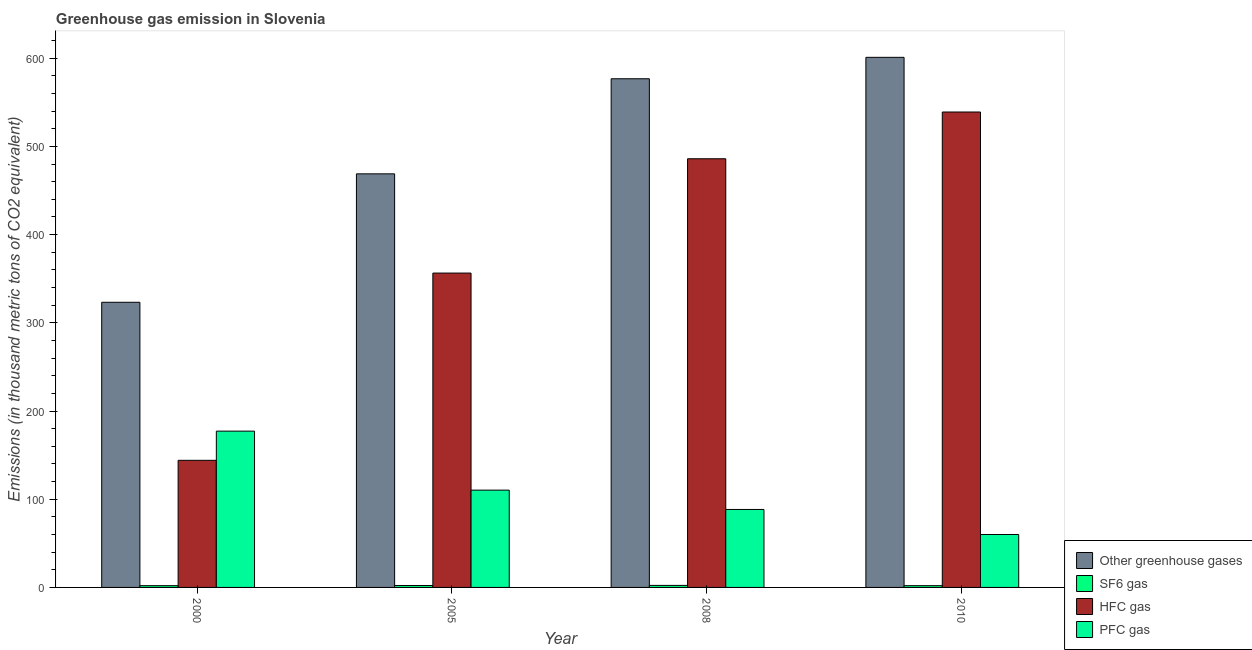How many groups of bars are there?
Ensure brevity in your answer.  4. Are the number of bars per tick equal to the number of legend labels?
Offer a very short reply. Yes. Are the number of bars on each tick of the X-axis equal?
Your response must be concise. Yes. What is the label of the 4th group of bars from the left?
Offer a terse response. 2010. In how many cases, is the number of bars for a given year not equal to the number of legend labels?
Give a very brief answer. 0. What is the emission of sf6 gas in 2000?
Your response must be concise. 2. Across all years, what is the maximum emission of greenhouse gases?
Provide a succinct answer. 601. What is the total emission of pfc gas in the graph?
Give a very brief answer. 435.9. What is the difference between the emission of sf6 gas in 2005 and the emission of pfc gas in 2008?
Your answer should be very brief. -0.1. What is the average emission of sf6 gas per year?
Offer a very short reply. 2.12. In how many years, is the emission of greenhouse gases greater than 500 thousand metric tons?
Give a very brief answer. 2. What is the ratio of the emission of sf6 gas in 2000 to that in 2008?
Ensure brevity in your answer.  0.87. Is the emission of greenhouse gases in 2000 less than that in 2010?
Offer a very short reply. Yes. What is the difference between the highest and the second highest emission of pfc gas?
Give a very brief answer. 66.9. What is the difference between the highest and the lowest emission of pfc gas?
Offer a very short reply. 117.2. What does the 4th bar from the left in 2005 represents?
Keep it short and to the point. PFC gas. What does the 1st bar from the right in 2000 represents?
Ensure brevity in your answer.  PFC gas. Is it the case that in every year, the sum of the emission of greenhouse gases and emission of sf6 gas is greater than the emission of hfc gas?
Keep it short and to the point. Yes. Are all the bars in the graph horizontal?
Offer a very short reply. No. How many years are there in the graph?
Your answer should be compact. 4. What is the difference between two consecutive major ticks on the Y-axis?
Ensure brevity in your answer.  100. Does the graph contain any zero values?
Offer a terse response. No. Does the graph contain grids?
Your response must be concise. No. How many legend labels are there?
Your response must be concise. 4. How are the legend labels stacked?
Offer a terse response. Vertical. What is the title of the graph?
Ensure brevity in your answer.  Greenhouse gas emission in Slovenia. What is the label or title of the X-axis?
Your answer should be very brief. Year. What is the label or title of the Y-axis?
Ensure brevity in your answer.  Emissions (in thousand metric tons of CO2 equivalent). What is the Emissions (in thousand metric tons of CO2 equivalent) in Other greenhouse gases in 2000?
Make the answer very short. 323.3. What is the Emissions (in thousand metric tons of CO2 equivalent) of HFC gas in 2000?
Keep it short and to the point. 144.1. What is the Emissions (in thousand metric tons of CO2 equivalent) of PFC gas in 2000?
Your response must be concise. 177.2. What is the Emissions (in thousand metric tons of CO2 equivalent) of Other greenhouse gases in 2005?
Provide a succinct answer. 468.9. What is the Emissions (in thousand metric tons of CO2 equivalent) of HFC gas in 2005?
Offer a very short reply. 356.4. What is the Emissions (in thousand metric tons of CO2 equivalent) in PFC gas in 2005?
Provide a short and direct response. 110.3. What is the Emissions (in thousand metric tons of CO2 equivalent) of Other greenhouse gases in 2008?
Your answer should be compact. 576.7. What is the Emissions (in thousand metric tons of CO2 equivalent) of HFC gas in 2008?
Give a very brief answer. 486. What is the Emissions (in thousand metric tons of CO2 equivalent) in PFC gas in 2008?
Provide a succinct answer. 88.4. What is the Emissions (in thousand metric tons of CO2 equivalent) of Other greenhouse gases in 2010?
Your answer should be very brief. 601. What is the Emissions (in thousand metric tons of CO2 equivalent) of HFC gas in 2010?
Your answer should be compact. 539. Across all years, what is the maximum Emissions (in thousand metric tons of CO2 equivalent) of Other greenhouse gases?
Ensure brevity in your answer.  601. Across all years, what is the maximum Emissions (in thousand metric tons of CO2 equivalent) of HFC gas?
Offer a terse response. 539. Across all years, what is the maximum Emissions (in thousand metric tons of CO2 equivalent) in PFC gas?
Offer a terse response. 177.2. Across all years, what is the minimum Emissions (in thousand metric tons of CO2 equivalent) in Other greenhouse gases?
Give a very brief answer. 323.3. Across all years, what is the minimum Emissions (in thousand metric tons of CO2 equivalent) of HFC gas?
Your answer should be compact. 144.1. Across all years, what is the minimum Emissions (in thousand metric tons of CO2 equivalent) of PFC gas?
Provide a succinct answer. 60. What is the total Emissions (in thousand metric tons of CO2 equivalent) in Other greenhouse gases in the graph?
Your response must be concise. 1969.9. What is the total Emissions (in thousand metric tons of CO2 equivalent) in SF6 gas in the graph?
Provide a succinct answer. 8.5. What is the total Emissions (in thousand metric tons of CO2 equivalent) in HFC gas in the graph?
Your answer should be compact. 1525.5. What is the total Emissions (in thousand metric tons of CO2 equivalent) in PFC gas in the graph?
Give a very brief answer. 435.9. What is the difference between the Emissions (in thousand metric tons of CO2 equivalent) of Other greenhouse gases in 2000 and that in 2005?
Ensure brevity in your answer.  -145.6. What is the difference between the Emissions (in thousand metric tons of CO2 equivalent) of SF6 gas in 2000 and that in 2005?
Your answer should be compact. -0.2. What is the difference between the Emissions (in thousand metric tons of CO2 equivalent) of HFC gas in 2000 and that in 2005?
Your answer should be very brief. -212.3. What is the difference between the Emissions (in thousand metric tons of CO2 equivalent) of PFC gas in 2000 and that in 2005?
Your response must be concise. 66.9. What is the difference between the Emissions (in thousand metric tons of CO2 equivalent) in Other greenhouse gases in 2000 and that in 2008?
Keep it short and to the point. -253.4. What is the difference between the Emissions (in thousand metric tons of CO2 equivalent) in HFC gas in 2000 and that in 2008?
Give a very brief answer. -341.9. What is the difference between the Emissions (in thousand metric tons of CO2 equivalent) in PFC gas in 2000 and that in 2008?
Your answer should be compact. 88.8. What is the difference between the Emissions (in thousand metric tons of CO2 equivalent) of Other greenhouse gases in 2000 and that in 2010?
Your answer should be compact. -277.7. What is the difference between the Emissions (in thousand metric tons of CO2 equivalent) of SF6 gas in 2000 and that in 2010?
Offer a very short reply. 0. What is the difference between the Emissions (in thousand metric tons of CO2 equivalent) in HFC gas in 2000 and that in 2010?
Provide a succinct answer. -394.9. What is the difference between the Emissions (in thousand metric tons of CO2 equivalent) in PFC gas in 2000 and that in 2010?
Your response must be concise. 117.2. What is the difference between the Emissions (in thousand metric tons of CO2 equivalent) of Other greenhouse gases in 2005 and that in 2008?
Make the answer very short. -107.8. What is the difference between the Emissions (in thousand metric tons of CO2 equivalent) in HFC gas in 2005 and that in 2008?
Provide a short and direct response. -129.6. What is the difference between the Emissions (in thousand metric tons of CO2 equivalent) in PFC gas in 2005 and that in 2008?
Offer a very short reply. 21.9. What is the difference between the Emissions (in thousand metric tons of CO2 equivalent) of Other greenhouse gases in 2005 and that in 2010?
Provide a short and direct response. -132.1. What is the difference between the Emissions (in thousand metric tons of CO2 equivalent) in SF6 gas in 2005 and that in 2010?
Ensure brevity in your answer.  0.2. What is the difference between the Emissions (in thousand metric tons of CO2 equivalent) in HFC gas in 2005 and that in 2010?
Keep it short and to the point. -182.6. What is the difference between the Emissions (in thousand metric tons of CO2 equivalent) of PFC gas in 2005 and that in 2010?
Give a very brief answer. 50.3. What is the difference between the Emissions (in thousand metric tons of CO2 equivalent) of Other greenhouse gases in 2008 and that in 2010?
Your response must be concise. -24.3. What is the difference between the Emissions (in thousand metric tons of CO2 equivalent) in SF6 gas in 2008 and that in 2010?
Your answer should be compact. 0.3. What is the difference between the Emissions (in thousand metric tons of CO2 equivalent) of HFC gas in 2008 and that in 2010?
Give a very brief answer. -53. What is the difference between the Emissions (in thousand metric tons of CO2 equivalent) in PFC gas in 2008 and that in 2010?
Your answer should be very brief. 28.4. What is the difference between the Emissions (in thousand metric tons of CO2 equivalent) in Other greenhouse gases in 2000 and the Emissions (in thousand metric tons of CO2 equivalent) in SF6 gas in 2005?
Give a very brief answer. 321.1. What is the difference between the Emissions (in thousand metric tons of CO2 equivalent) of Other greenhouse gases in 2000 and the Emissions (in thousand metric tons of CO2 equivalent) of HFC gas in 2005?
Offer a terse response. -33.1. What is the difference between the Emissions (in thousand metric tons of CO2 equivalent) in Other greenhouse gases in 2000 and the Emissions (in thousand metric tons of CO2 equivalent) in PFC gas in 2005?
Provide a succinct answer. 213. What is the difference between the Emissions (in thousand metric tons of CO2 equivalent) of SF6 gas in 2000 and the Emissions (in thousand metric tons of CO2 equivalent) of HFC gas in 2005?
Your answer should be compact. -354.4. What is the difference between the Emissions (in thousand metric tons of CO2 equivalent) in SF6 gas in 2000 and the Emissions (in thousand metric tons of CO2 equivalent) in PFC gas in 2005?
Provide a short and direct response. -108.3. What is the difference between the Emissions (in thousand metric tons of CO2 equivalent) in HFC gas in 2000 and the Emissions (in thousand metric tons of CO2 equivalent) in PFC gas in 2005?
Ensure brevity in your answer.  33.8. What is the difference between the Emissions (in thousand metric tons of CO2 equivalent) in Other greenhouse gases in 2000 and the Emissions (in thousand metric tons of CO2 equivalent) in SF6 gas in 2008?
Give a very brief answer. 321. What is the difference between the Emissions (in thousand metric tons of CO2 equivalent) in Other greenhouse gases in 2000 and the Emissions (in thousand metric tons of CO2 equivalent) in HFC gas in 2008?
Your answer should be very brief. -162.7. What is the difference between the Emissions (in thousand metric tons of CO2 equivalent) in Other greenhouse gases in 2000 and the Emissions (in thousand metric tons of CO2 equivalent) in PFC gas in 2008?
Offer a terse response. 234.9. What is the difference between the Emissions (in thousand metric tons of CO2 equivalent) of SF6 gas in 2000 and the Emissions (in thousand metric tons of CO2 equivalent) of HFC gas in 2008?
Provide a succinct answer. -484. What is the difference between the Emissions (in thousand metric tons of CO2 equivalent) in SF6 gas in 2000 and the Emissions (in thousand metric tons of CO2 equivalent) in PFC gas in 2008?
Keep it short and to the point. -86.4. What is the difference between the Emissions (in thousand metric tons of CO2 equivalent) of HFC gas in 2000 and the Emissions (in thousand metric tons of CO2 equivalent) of PFC gas in 2008?
Provide a short and direct response. 55.7. What is the difference between the Emissions (in thousand metric tons of CO2 equivalent) in Other greenhouse gases in 2000 and the Emissions (in thousand metric tons of CO2 equivalent) in SF6 gas in 2010?
Keep it short and to the point. 321.3. What is the difference between the Emissions (in thousand metric tons of CO2 equivalent) in Other greenhouse gases in 2000 and the Emissions (in thousand metric tons of CO2 equivalent) in HFC gas in 2010?
Give a very brief answer. -215.7. What is the difference between the Emissions (in thousand metric tons of CO2 equivalent) in Other greenhouse gases in 2000 and the Emissions (in thousand metric tons of CO2 equivalent) in PFC gas in 2010?
Your answer should be compact. 263.3. What is the difference between the Emissions (in thousand metric tons of CO2 equivalent) in SF6 gas in 2000 and the Emissions (in thousand metric tons of CO2 equivalent) in HFC gas in 2010?
Keep it short and to the point. -537. What is the difference between the Emissions (in thousand metric tons of CO2 equivalent) in SF6 gas in 2000 and the Emissions (in thousand metric tons of CO2 equivalent) in PFC gas in 2010?
Offer a very short reply. -58. What is the difference between the Emissions (in thousand metric tons of CO2 equivalent) of HFC gas in 2000 and the Emissions (in thousand metric tons of CO2 equivalent) of PFC gas in 2010?
Provide a succinct answer. 84.1. What is the difference between the Emissions (in thousand metric tons of CO2 equivalent) in Other greenhouse gases in 2005 and the Emissions (in thousand metric tons of CO2 equivalent) in SF6 gas in 2008?
Provide a succinct answer. 466.6. What is the difference between the Emissions (in thousand metric tons of CO2 equivalent) of Other greenhouse gases in 2005 and the Emissions (in thousand metric tons of CO2 equivalent) of HFC gas in 2008?
Give a very brief answer. -17.1. What is the difference between the Emissions (in thousand metric tons of CO2 equivalent) in Other greenhouse gases in 2005 and the Emissions (in thousand metric tons of CO2 equivalent) in PFC gas in 2008?
Provide a short and direct response. 380.5. What is the difference between the Emissions (in thousand metric tons of CO2 equivalent) in SF6 gas in 2005 and the Emissions (in thousand metric tons of CO2 equivalent) in HFC gas in 2008?
Provide a succinct answer. -483.8. What is the difference between the Emissions (in thousand metric tons of CO2 equivalent) in SF6 gas in 2005 and the Emissions (in thousand metric tons of CO2 equivalent) in PFC gas in 2008?
Make the answer very short. -86.2. What is the difference between the Emissions (in thousand metric tons of CO2 equivalent) of HFC gas in 2005 and the Emissions (in thousand metric tons of CO2 equivalent) of PFC gas in 2008?
Provide a succinct answer. 268. What is the difference between the Emissions (in thousand metric tons of CO2 equivalent) of Other greenhouse gases in 2005 and the Emissions (in thousand metric tons of CO2 equivalent) of SF6 gas in 2010?
Keep it short and to the point. 466.9. What is the difference between the Emissions (in thousand metric tons of CO2 equivalent) in Other greenhouse gases in 2005 and the Emissions (in thousand metric tons of CO2 equivalent) in HFC gas in 2010?
Your answer should be compact. -70.1. What is the difference between the Emissions (in thousand metric tons of CO2 equivalent) of Other greenhouse gases in 2005 and the Emissions (in thousand metric tons of CO2 equivalent) of PFC gas in 2010?
Offer a terse response. 408.9. What is the difference between the Emissions (in thousand metric tons of CO2 equivalent) in SF6 gas in 2005 and the Emissions (in thousand metric tons of CO2 equivalent) in HFC gas in 2010?
Offer a terse response. -536.8. What is the difference between the Emissions (in thousand metric tons of CO2 equivalent) of SF6 gas in 2005 and the Emissions (in thousand metric tons of CO2 equivalent) of PFC gas in 2010?
Offer a terse response. -57.8. What is the difference between the Emissions (in thousand metric tons of CO2 equivalent) of HFC gas in 2005 and the Emissions (in thousand metric tons of CO2 equivalent) of PFC gas in 2010?
Ensure brevity in your answer.  296.4. What is the difference between the Emissions (in thousand metric tons of CO2 equivalent) in Other greenhouse gases in 2008 and the Emissions (in thousand metric tons of CO2 equivalent) in SF6 gas in 2010?
Your answer should be very brief. 574.7. What is the difference between the Emissions (in thousand metric tons of CO2 equivalent) in Other greenhouse gases in 2008 and the Emissions (in thousand metric tons of CO2 equivalent) in HFC gas in 2010?
Keep it short and to the point. 37.7. What is the difference between the Emissions (in thousand metric tons of CO2 equivalent) of Other greenhouse gases in 2008 and the Emissions (in thousand metric tons of CO2 equivalent) of PFC gas in 2010?
Offer a very short reply. 516.7. What is the difference between the Emissions (in thousand metric tons of CO2 equivalent) of SF6 gas in 2008 and the Emissions (in thousand metric tons of CO2 equivalent) of HFC gas in 2010?
Keep it short and to the point. -536.7. What is the difference between the Emissions (in thousand metric tons of CO2 equivalent) of SF6 gas in 2008 and the Emissions (in thousand metric tons of CO2 equivalent) of PFC gas in 2010?
Provide a short and direct response. -57.7. What is the difference between the Emissions (in thousand metric tons of CO2 equivalent) of HFC gas in 2008 and the Emissions (in thousand metric tons of CO2 equivalent) of PFC gas in 2010?
Your response must be concise. 426. What is the average Emissions (in thousand metric tons of CO2 equivalent) of Other greenhouse gases per year?
Your answer should be compact. 492.48. What is the average Emissions (in thousand metric tons of CO2 equivalent) of SF6 gas per year?
Ensure brevity in your answer.  2.12. What is the average Emissions (in thousand metric tons of CO2 equivalent) in HFC gas per year?
Provide a short and direct response. 381.38. What is the average Emissions (in thousand metric tons of CO2 equivalent) in PFC gas per year?
Your answer should be compact. 108.97. In the year 2000, what is the difference between the Emissions (in thousand metric tons of CO2 equivalent) in Other greenhouse gases and Emissions (in thousand metric tons of CO2 equivalent) in SF6 gas?
Your answer should be compact. 321.3. In the year 2000, what is the difference between the Emissions (in thousand metric tons of CO2 equivalent) in Other greenhouse gases and Emissions (in thousand metric tons of CO2 equivalent) in HFC gas?
Ensure brevity in your answer.  179.2. In the year 2000, what is the difference between the Emissions (in thousand metric tons of CO2 equivalent) in Other greenhouse gases and Emissions (in thousand metric tons of CO2 equivalent) in PFC gas?
Offer a terse response. 146.1. In the year 2000, what is the difference between the Emissions (in thousand metric tons of CO2 equivalent) in SF6 gas and Emissions (in thousand metric tons of CO2 equivalent) in HFC gas?
Keep it short and to the point. -142.1. In the year 2000, what is the difference between the Emissions (in thousand metric tons of CO2 equivalent) in SF6 gas and Emissions (in thousand metric tons of CO2 equivalent) in PFC gas?
Offer a terse response. -175.2. In the year 2000, what is the difference between the Emissions (in thousand metric tons of CO2 equivalent) in HFC gas and Emissions (in thousand metric tons of CO2 equivalent) in PFC gas?
Offer a terse response. -33.1. In the year 2005, what is the difference between the Emissions (in thousand metric tons of CO2 equivalent) in Other greenhouse gases and Emissions (in thousand metric tons of CO2 equivalent) in SF6 gas?
Provide a succinct answer. 466.7. In the year 2005, what is the difference between the Emissions (in thousand metric tons of CO2 equivalent) in Other greenhouse gases and Emissions (in thousand metric tons of CO2 equivalent) in HFC gas?
Offer a terse response. 112.5. In the year 2005, what is the difference between the Emissions (in thousand metric tons of CO2 equivalent) in Other greenhouse gases and Emissions (in thousand metric tons of CO2 equivalent) in PFC gas?
Provide a short and direct response. 358.6. In the year 2005, what is the difference between the Emissions (in thousand metric tons of CO2 equivalent) in SF6 gas and Emissions (in thousand metric tons of CO2 equivalent) in HFC gas?
Ensure brevity in your answer.  -354.2. In the year 2005, what is the difference between the Emissions (in thousand metric tons of CO2 equivalent) in SF6 gas and Emissions (in thousand metric tons of CO2 equivalent) in PFC gas?
Your response must be concise. -108.1. In the year 2005, what is the difference between the Emissions (in thousand metric tons of CO2 equivalent) of HFC gas and Emissions (in thousand metric tons of CO2 equivalent) of PFC gas?
Your answer should be very brief. 246.1. In the year 2008, what is the difference between the Emissions (in thousand metric tons of CO2 equivalent) in Other greenhouse gases and Emissions (in thousand metric tons of CO2 equivalent) in SF6 gas?
Your answer should be very brief. 574.4. In the year 2008, what is the difference between the Emissions (in thousand metric tons of CO2 equivalent) in Other greenhouse gases and Emissions (in thousand metric tons of CO2 equivalent) in HFC gas?
Provide a short and direct response. 90.7. In the year 2008, what is the difference between the Emissions (in thousand metric tons of CO2 equivalent) of Other greenhouse gases and Emissions (in thousand metric tons of CO2 equivalent) of PFC gas?
Make the answer very short. 488.3. In the year 2008, what is the difference between the Emissions (in thousand metric tons of CO2 equivalent) of SF6 gas and Emissions (in thousand metric tons of CO2 equivalent) of HFC gas?
Make the answer very short. -483.7. In the year 2008, what is the difference between the Emissions (in thousand metric tons of CO2 equivalent) in SF6 gas and Emissions (in thousand metric tons of CO2 equivalent) in PFC gas?
Keep it short and to the point. -86.1. In the year 2008, what is the difference between the Emissions (in thousand metric tons of CO2 equivalent) of HFC gas and Emissions (in thousand metric tons of CO2 equivalent) of PFC gas?
Your response must be concise. 397.6. In the year 2010, what is the difference between the Emissions (in thousand metric tons of CO2 equivalent) in Other greenhouse gases and Emissions (in thousand metric tons of CO2 equivalent) in SF6 gas?
Your answer should be very brief. 599. In the year 2010, what is the difference between the Emissions (in thousand metric tons of CO2 equivalent) in Other greenhouse gases and Emissions (in thousand metric tons of CO2 equivalent) in HFC gas?
Keep it short and to the point. 62. In the year 2010, what is the difference between the Emissions (in thousand metric tons of CO2 equivalent) of Other greenhouse gases and Emissions (in thousand metric tons of CO2 equivalent) of PFC gas?
Ensure brevity in your answer.  541. In the year 2010, what is the difference between the Emissions (in thousand metric tons of CO2 equivalent) in SF6 gas and Emissions (in thousand metric tons of CO2 equivalent) in HFC gas?
Offer a terse response. -537. In the year 2010, what is the difference between the Emissions (in thousand metric tons of CO2 equivalent) of SF6 gas and Emissions (in thousand metric tons of CO2 equivalent) of PFC gas?
Make the answer very short. -58. In the year 2010, what is the difference between the Emissions (in thousand metric tons of CO2 equivalent) in HFC gas and Emissions (in thousand metric tons of CO2 equivalent) in PFC gas?
Your response must be concise. 479. What is the ratio of the Emissions (in thousand metric tons of CO2 equivalent) of Other greenhouse gases in 2000 to that in 2005?
Your response must be concise. 0.69. What is the ratio of the Emissions (in thousand metric tons of CO2 equivalent) in SF6 gas in 2000 to that in 2005?
Your answer should be very brief. 0.91. What is the ratio of the Emissions (in thousand metric tons of CO2 equivalent) of HFC gas in 2000 to that in 2005?
Make the answer very short. 0.4. What is the ratio of the Emissions (in thousand metric tons of CO2 equivalent) in PFC gas in 2000 to that in 2005?
Offer a very short reply. 1.61. What is the ratio of the Emissions (in thousand metric tons of CO2 equivalent) in Other greenhouse gases in 2000 to that in 2008?
Offer a terse response. 0.56. What is the ratio of the Emissions (in thousand metric tons of CO2 equivalent) in SF6 gas in 2000 to that in 2008?
Give a very brief answer. 0.87. What is the ratio of the Emissions (in thousand metric tons of CO2 equivalent) in HFC gas in 2000 to that in 2008?
Give a very brief answer. 0.3. What is the ratio of the Emissions (in thousand metric tons of CO2 equivalent) in PFC gas in 2000 to that in 2008?
Provide a succinct answer. 2. What is the ratio of the Emissions (in thousand metric tons of CO2 equivalent) in Other greenhouse gases in 2000 to that in 2010?
Your response must be concise. 0.54. What is the ratio of the Emissions (in thousand metric tons of CO2 equivalent) of SF6 gas in 2000 to that in 2010?
Offer a terse response. 1. What is the ratio of the Emissions (in thousand metric tons of CO2 equivalent) of HFC gas in 2000 to that in 2010?
Your answer should be compact. 0.27. What is the ratio of the Emissions (in thousand metric tons of CO2 equivalent) in PFC gas in 2000 to that in 2010?
Your answer should be compact. 2.95. What is the ratio of the Emissions (in thousand metric tons of CO2 equivalent) of Other greenhouse gases in 2005 to that in 2008?
Your response must be concise. 0.81. What is the ratio of the Emissions (in thousand metric tons of CO2 equivalent) of SF6 gas in 2005 to that in 2008?
Offer a terse response. 0.96. What is the ratio of the Emissions (in thousand metric tons of CO2 equivalent) of HFC gas in 2005 to that in 2008?
Offer a terse response. 0.73. What is the ratio of the Emissions (in thousand metric tons of CO2 equivalent) in PFC gas in 2005 to that in 2008?
Your answer should be compact. 1.25. What is the ratio of the Emissions (in thousand metric tons of CO2 equivalent) of Other greenhouse gases in 2005 to that in 2010?
Ensure brevity in your answer.  0.78. What is the ratio of the Emissions (in thousand metric tons of CO2 equivalent) in SF6 gas in 2005 to that in 2010?
Your answer should be compact. 1.1. What is the ratio of the Emissions (in thousand metric tons of CO2 equivalent) of HFC gas in 2005 to that in 2010?
Your answer should be very brief. 0.66. What is the ratio of the Emissions (in thousand metric tons of CO2 equivalent) in PFC gas in 2005 to that in 2010?
Make the answer very short. 1.84. What is the ratio of the Emissions (in thousand metric tons of CO2 equivalent) of Other greenhouse gases in 2008 to that in 2010?
Provide a short and direct response. 0.96. What is the ratio of the Emissions (in thousand metric tons of CO2 equivalent) of SF6 gas in 2008 to that in 2010?
Provide a succinct answer. 1.15. What is the ratio of the Emissions (in thousand metric tons of CO2 equivalent) in HFC gas in 2008 to that in 2010?
Provide a short and direct response. 0.9. What is the ratio of the Emissions (in thousand metric tons of CO2 equivalent) of PFC gas in 2008 to that in 2010?
Your answer should be very brief. 1.47. What is the difference between the highest and the second highest Emissions (in thousand metric tons of CO2 equivalent) of Other greenhouse gases?
Your answer should be compact. 24.3. What is the difference between the highest and the second highest Emissions (in thousand metric tons of CO2 equivalent) of PFC gas?
Offer a terse response. 66.9. What is the difference between the highest and the lowest Emissions (in thousand metric tons of CO2 equivalent) in Other greenhouse gases?
Keep it short and to the point. 277.7. What is the difference between the highest and the lowest Emissions (in thousand metric tons of CO2 equivalent) of HFC gas?
Your response must be concise. 394.9. What is the difference between the highest and the lowest Emissions (in thousand metric tons of CO2 equivalent) in PFC gas?
Provide a short and direct response. 117.2. 